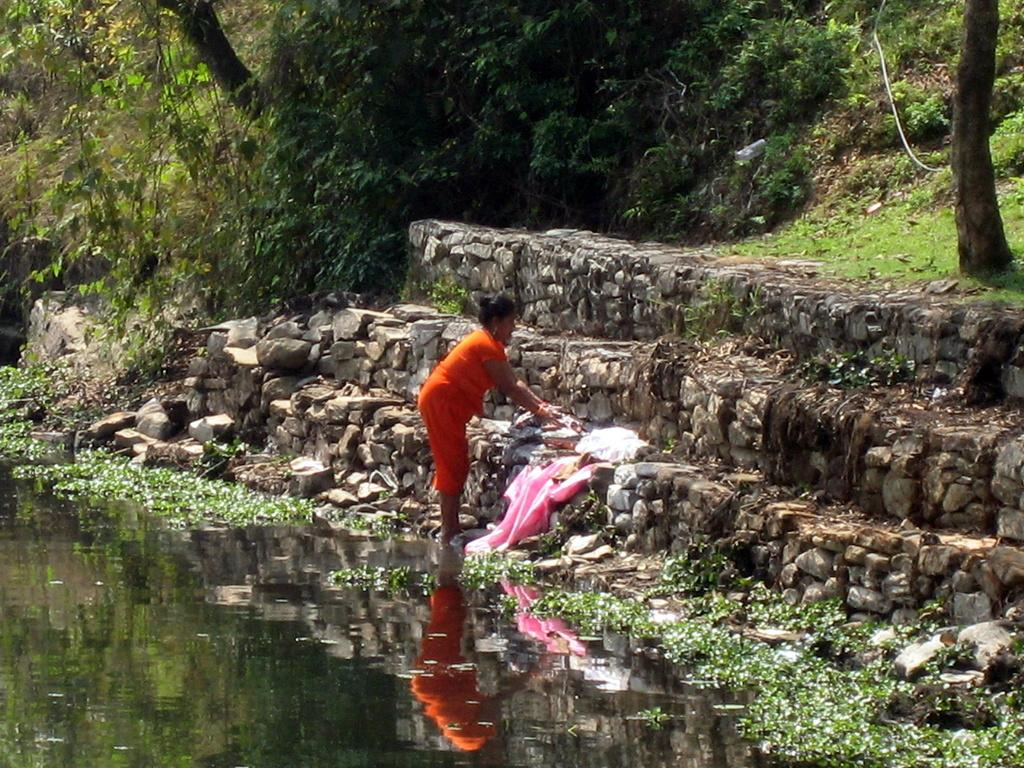What can be seen in the foreground of the picture? In the foreground of the picture, there are plants, water, and a staircase. What is the woman in the center of the picture doing? The woman is washing clothes in the center of the picture. What types of vegetation and natural elements can be seen at the top of the picture? At the top of the picture, there are trees, plants, and grass. Can you tell me how much the woman paid for the vein in the picture? There is no vein present in the picture, and the woman is not making any payments. What type of beam is supporting the staircase in the picture? There is no visible beam supporting the staircase in the picture; only the staircase itself is visible. 